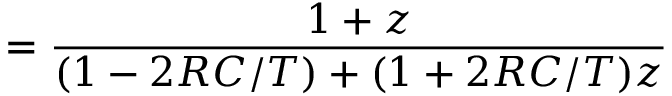Convert formula to latex. <formula><loc_0><loc_0><loc_500><loc_500>= { \frac { 1 + z } { ( 1 - 2 R C / T ) + ( 1 + 2 R C / T ) z } }</formula> 